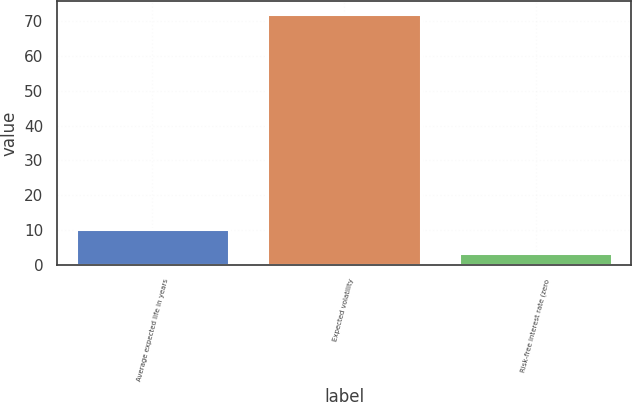Convert chart. <chart><loc_0><loc_0><loc_500><loc_500><bar_chart><fcel>Average expected life in years<fcel>Expected volatility<fcel>Risk-free interest rate (zero<nl><fcel>10.35<fcel>72<fcel>3.5<nl></chart> 